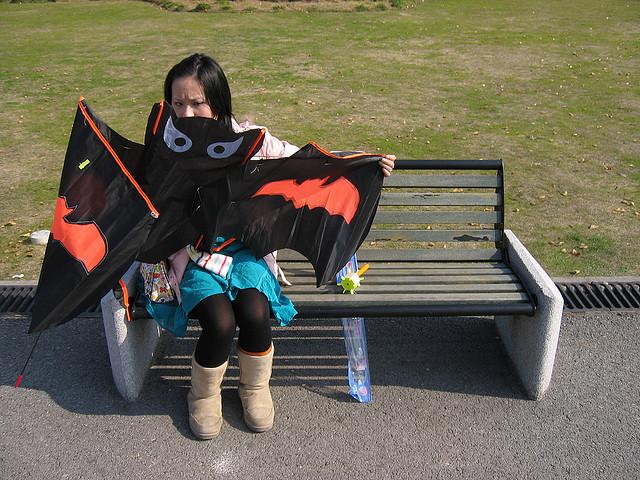Who is on the bench?
Be succinct. Woman. What is the item in her hand?
Concise answer only. Kite. What material are the bench legs made of?
Be succinct. Concrete. 